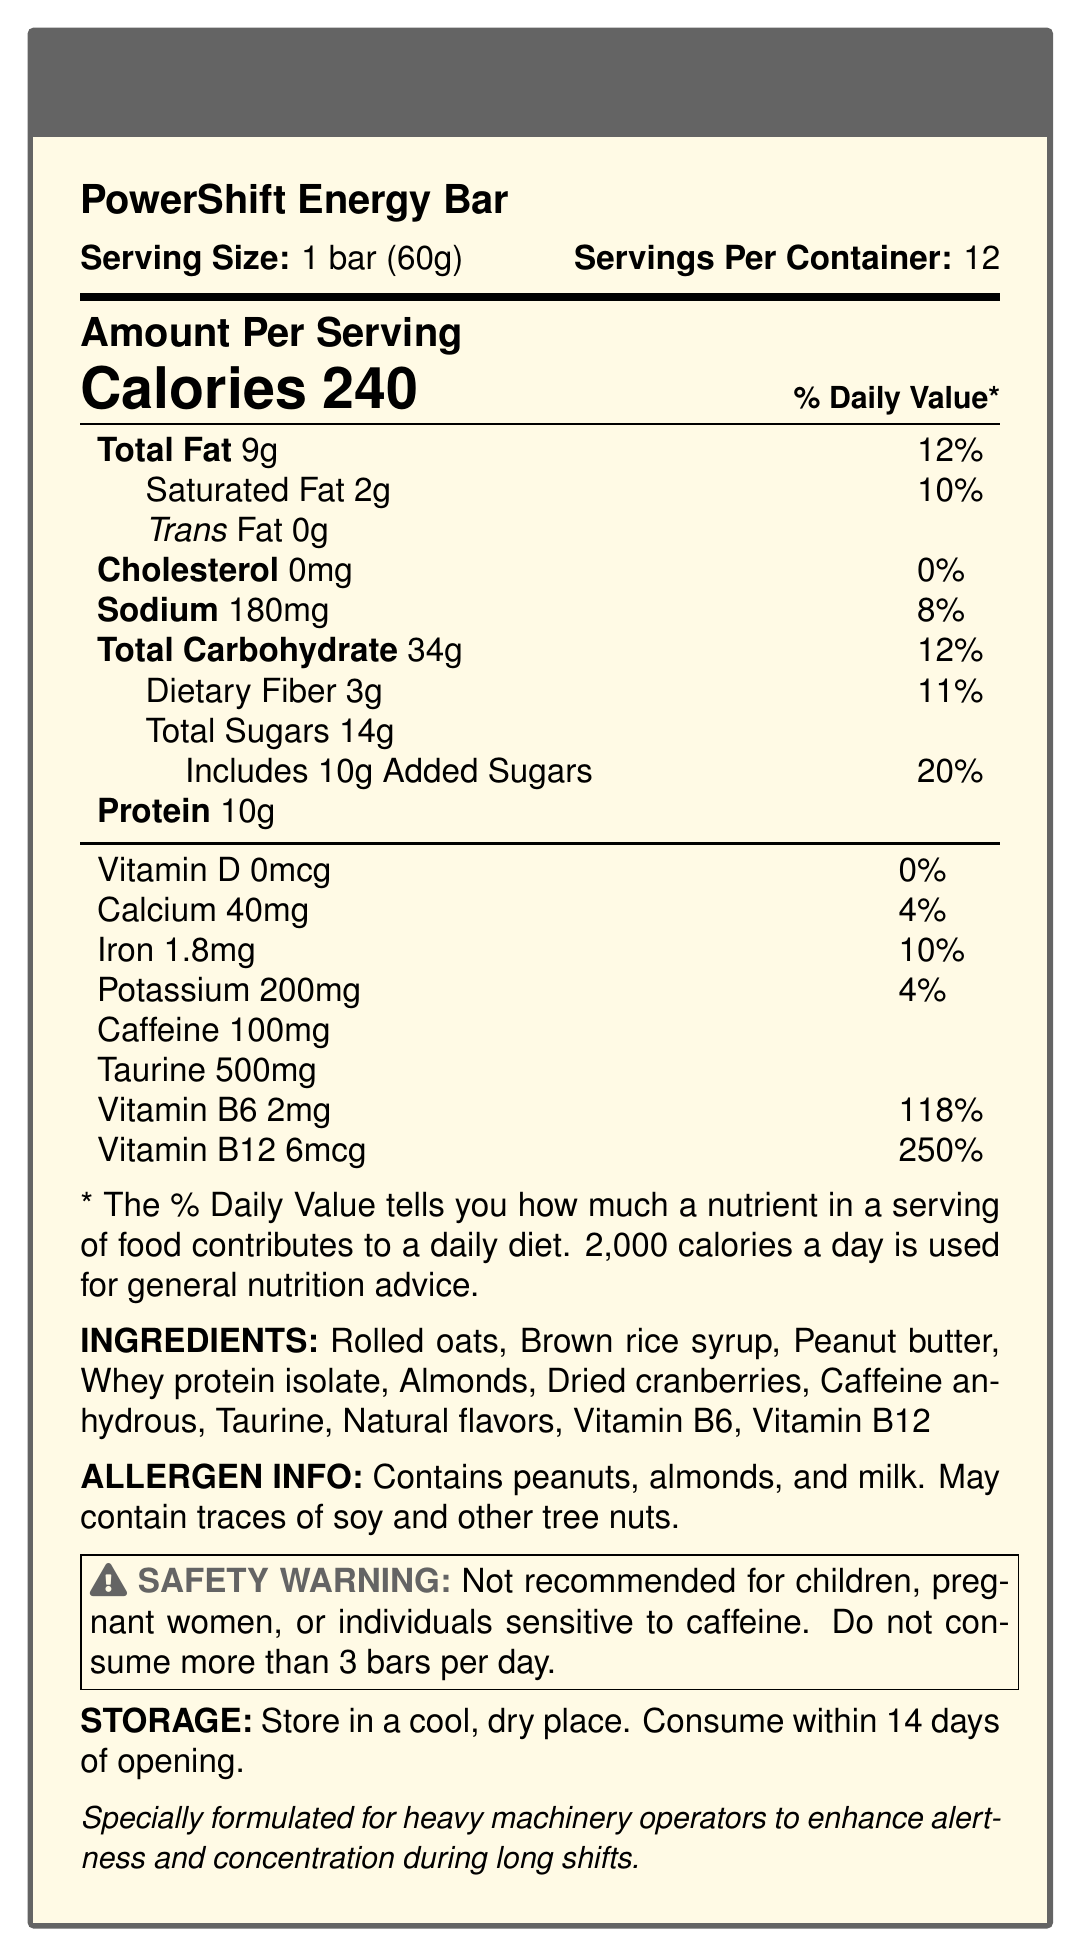what is the serving size of the PowerShift Energy Bar? The serving size is explicitly mentioned in the document as 1 bar (60g).
Answer: 1 bar (60g) How many servings are there per container? The document states that there are 12 servings per container.
Answer: 12 How much caffeine is in each serving of the PowerShift Energy Bar? The document lists 100mg of caffeine per serving.
Answer: 100mg What is the amount of protein in one bar? The document specifies that each bar contains 10g of protein.
Answer: 10g What vitamins are included in the PowerShift Energy Bar? According to the document, the vitamins included are Vitamin B6 and Vitamin B12.
Answer: Vitamin B6 and Vitamin B12 How much total carbohydrate is in one bar? The document indicates that there are 34g of total carbohydrates per serving.
Answer: 34g Which of the following is an ingredient in the PowerShift Energy Bar? A. Soy protein B. Brown rice syrup C. Cocoa powder The list of ingredients includes brown rice syrup but does not mention soy protein or cocoa powder.
Answer: B. Brown rice syrup What is the daily value percentage for saturated fat in one bar? A. 5% B. 10% C. 20% The document states that the daily value percentage for saturated fat is 10%.
Answer: B. 10% Is peanut butter one of the allergens in the PowerShift Energy Bar? (Yes/No) The allergen information states that the bar contains peanuts, and peanut butter is listed as an ingredient.
Answer: Yes Summarize the main purpose of the PowerShift Energy Bar. The document includes details on serving size, nutritional content, ingredients, and allergens, as well as special claims and safety warnings aimed at heavy machinery operators.
Answer: The PowerShift Energy Bar is specially formulated for heavy machinery operators to enhance alertness and concentration during long shifts. It contains a balanced mix of nutrients, including caffeine, taurine, and B-vitamins, to support these benefits while providing energy and protein. How much Vitamin D is in one bar? The document states there is no Vitamin D in each bar.
Answer: 0mcg What is the safety warning associated with the consumption of PowerShift Energy Bars? The safety warning explicitly mentions these groups and the recommended consumption limit.
Answer: Not recommended for children, pregnant women, or individuals sensitive to caffeine. Do not consume more than 3 bars per day. What is the sodium content in one bar? The document lists the sodium content as 180mg per serving.
Answer: 180mg What is the total amount of sugars in one bar, including added sugars? The document specifies 14g of total sugars and includes 10g of added sugars.
Answer: 14g total sugars, 10g added sugars Does each bar contain any trans fat? The document states there is 0g of trans fat per serving.
Answer: No How long should you consume the PowerShift Energy Bar after opening? The storage instructions indicate that the bar should be consumed within 14 days of opening.
Answer: Within 14 days How much taurine is in each bar? The nutritional information lists 500mg of taurine per bar.
Answer: 500mg Are there any tree nuts in the PowerShift Energy Bar? The allergen info states it contains almonds and may contain traces of other tree nuts.
Answer: Yes What are the natural flavors included in the PowerShift Energy Bar? The document lists "Natural flavors" as an ingredient but does not specify what those natural flavors are.
Answer: Cannot be determined 